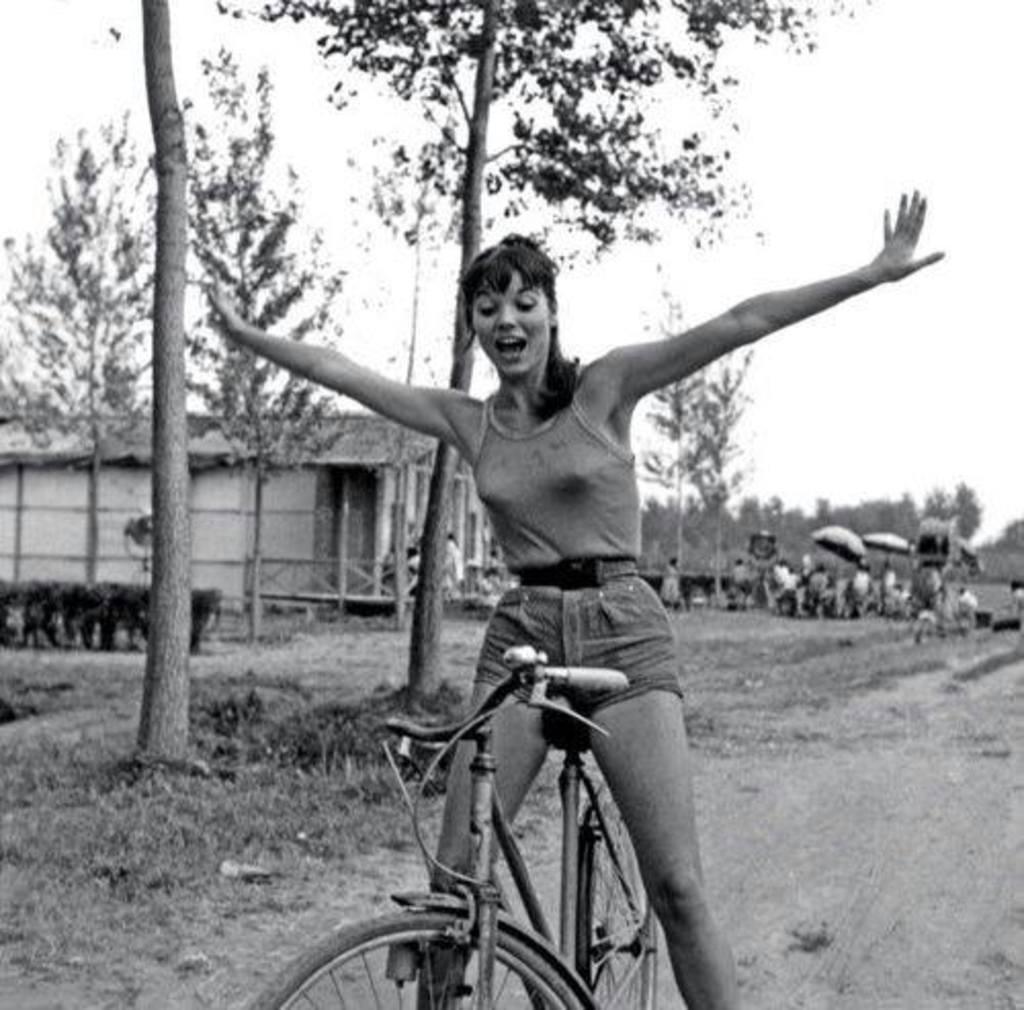Can you describe this image briefly? This is a black and white picture. In this image we can see one woman sitting on a bicycle, some tents, one house with a fence, so many trees, plants, bushes and grass. There are so many people, some people are standing and some people are sitting. Some objects are on the surface and at the top there is the sky. 